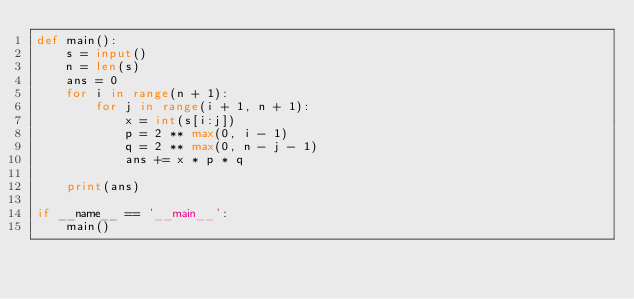<code> <loc_0><loc_0><loc_500><loc_500><_Python_>def main():
    s = input()
    n = len(s)
    ans = 0
    for i in range(n + 1):
        for j in range(i + 1, n + 1):
            x = int(s[i:j])
            p = 2 ** max(0, i - 1)
            q = 2 ** max(0, n - j - 1)
            ans += x * p * q

    print(ans)

if __name__ == '__main__':
    main()
</code> 